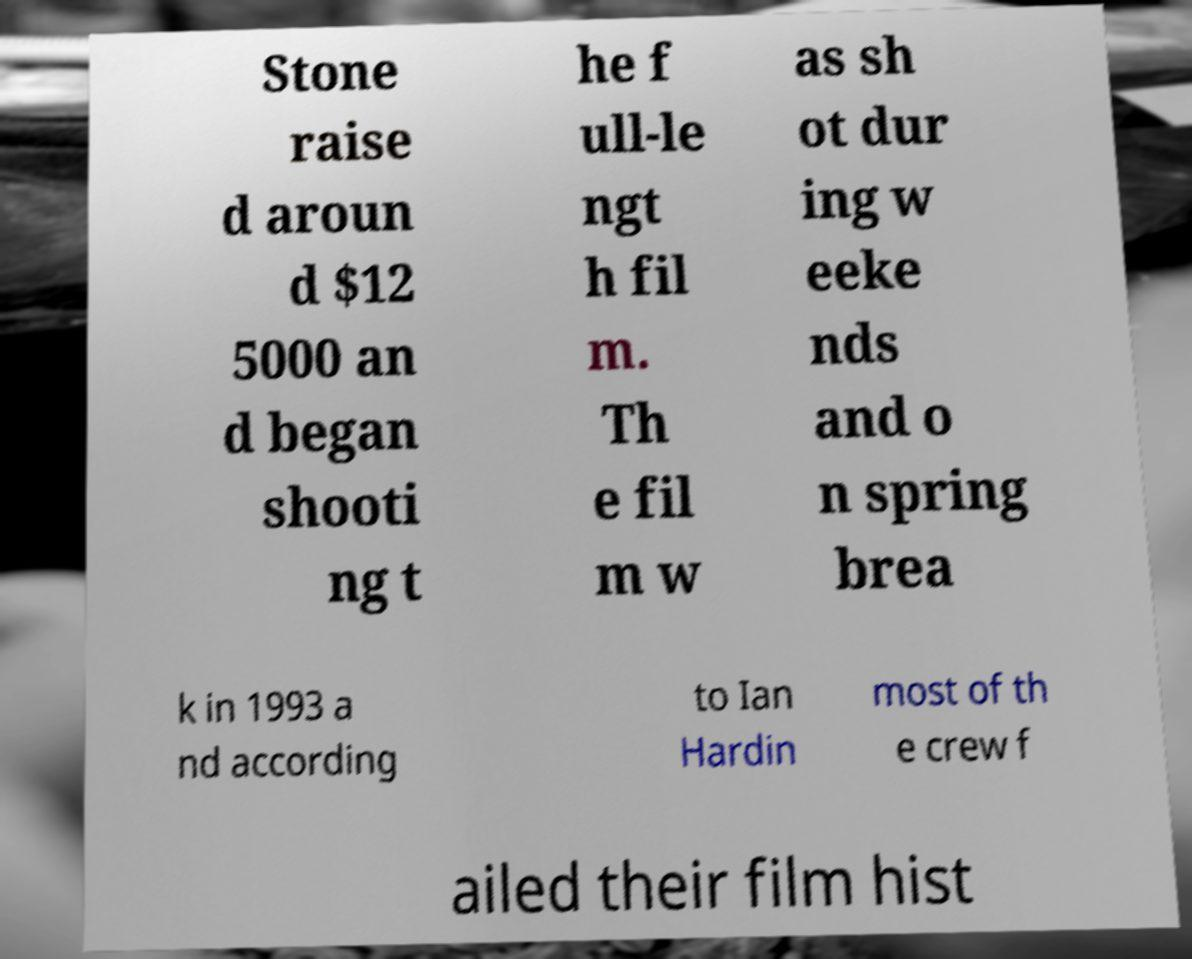There's text embedded in this image that I need extracted. Can you transcribe it verbatim? Stone raise d aroun d $12 5000 an d began shooti ng t he f ull-le ngt h fil m. Th e fil m w as sh ot dur ing w eeke nds and o n spring brea k in 1993 a nd according to Ian Hardin most of th e crew f ailed their film hist 